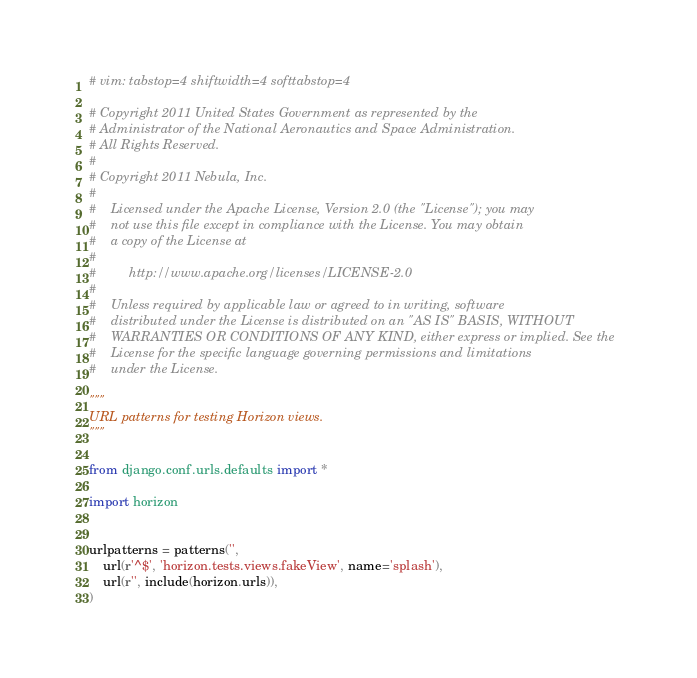Convert code to text. <code><loc_0><loc_0><loc_500><loc_500><_Python_># vim: tabstop=4 shiftwidth=4 softtabstop=4

# Copyright 2011 United States Government as represented by the
# Administrator of the National Aeronautics and Space Administration.
# All Rights Reserved.
#
# Copyright 2011 Nebula, Inc.
#
#    Licensed under the Apache License, Version 2.0 (the "License"); you may
#    not use this file except in compliance with the License. You may obtain
#    a copy of the License at
#
#         http://www.apache.org/licenses/LICENSE-2.0
#
#    Unless required by applicable law or agreed to in writing, software
#    distributed under the License is distributed on an "AS IS" BASIS, WITHOUT
#    WARRANTIES OR CONDITIONS OF ANY KIND, either express or implied. See the
#    License for the specific language governing permissions and limitations
#    under the License.

"""
URL patterns for testing Horizon views.
"""

from django.conf.urls.defaults import *

import horizon


urlpatterns = patterns('',
    url(r'^$', 'horizon.tests.views.fakeView', name='splash'),
    url(r'', include(horizon.urls)),
)
</code> 